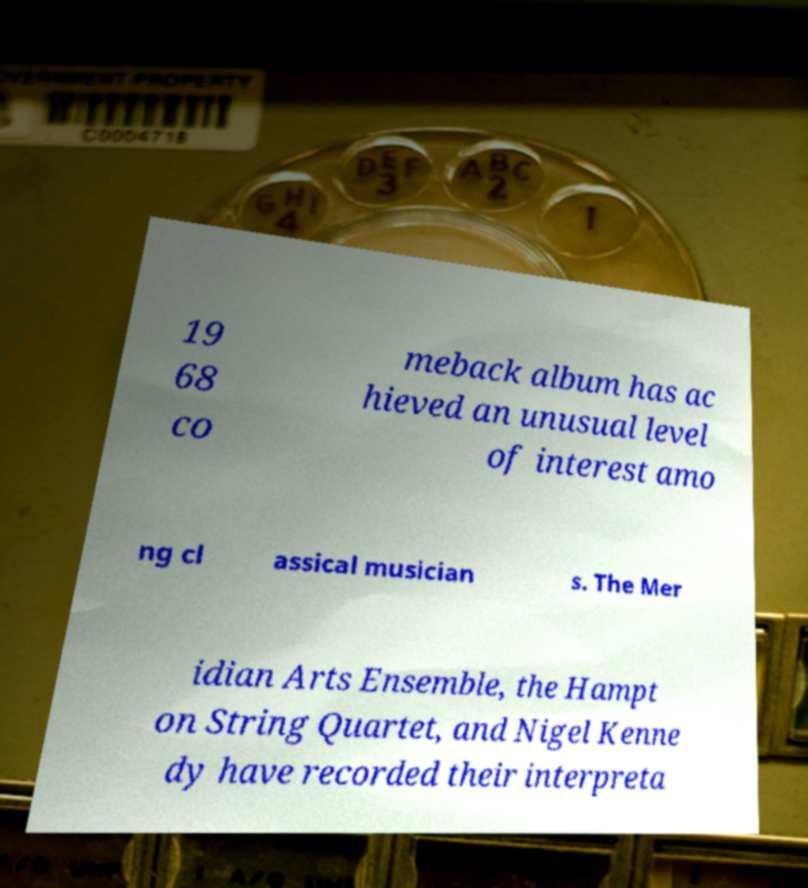Please identify and transcribe the text found in this image. 19 68 co meback album has ac hieved an unusual level of interest amo ng cl assical musician s. The Mer idian Arts Ensemble, the Hampt on String Quartet, and Nigel Kenne dy have recorded their interpreta 